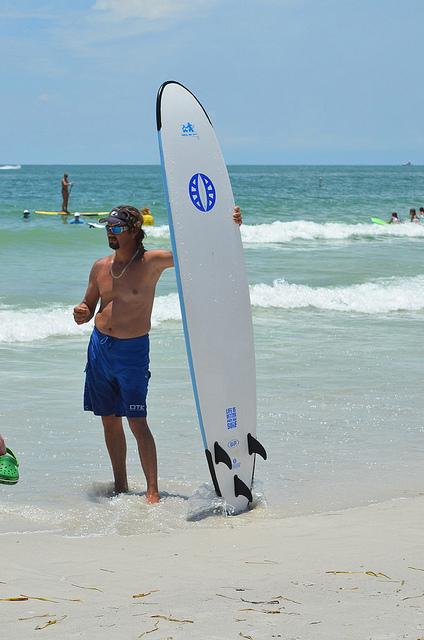Does this surfboard look new?
Be succinct. Yes. What is in the picture?
Write a very short answer. Man with surfboard. What color is the man's shorts?
Be succinct. Blue. Is this on the beach?
Concise answer only. Yes. 